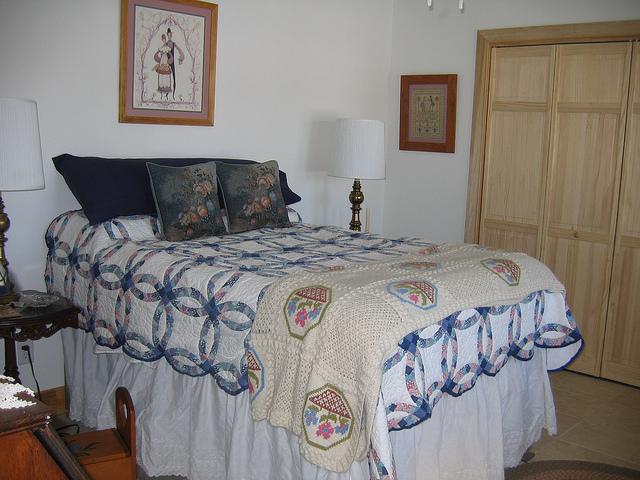How many pillows do you see?
Quick response, please. 3. How many lamps do you see?
Keep it brief. 2. What is that type of bed covering called?
Be succinct. Quilt. 